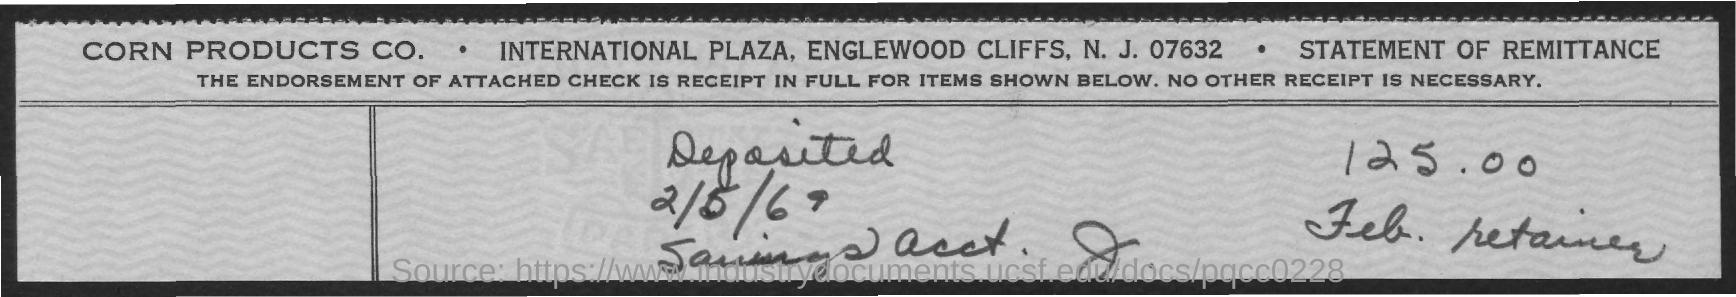What is the amount deposited as per the document?
Give a very brief answer. 125.00. What is the deposited date mentioned in this document?
Your answer should be very brief. 2/5/69. 